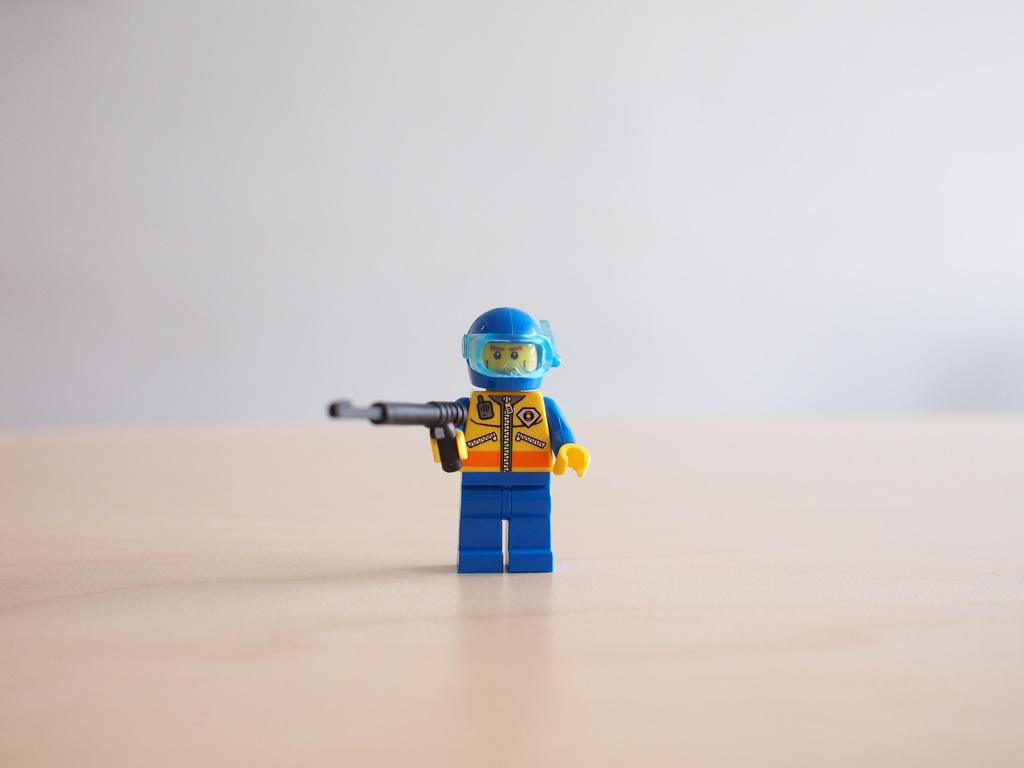What object can be seen in the image? There is a small toy in the image. What is the toy holding? The toy is holding a gun. Where is the toy located? The toy is on a table. What type of crack is visible in the image? There is no crack visible in the image. Is there a baby present in the image? No, there is no baby present in the image. 